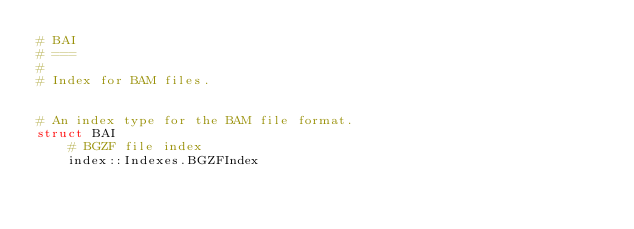<code> <loc_0><loc_0><loc_500><loc_500><_Julia_># BAI
# ===
#
# Index for BAM files.


# An index type for the BAM file format.
struct BAI
    # BGZF file index
    index::Indexes.BGZFIndex
</code> 